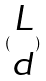Convert formula to latex. <formula><loc_0><loc_0><loc_500><loc_500>( \begin{matrix} L \\ d \end{matrix} )</formula> 